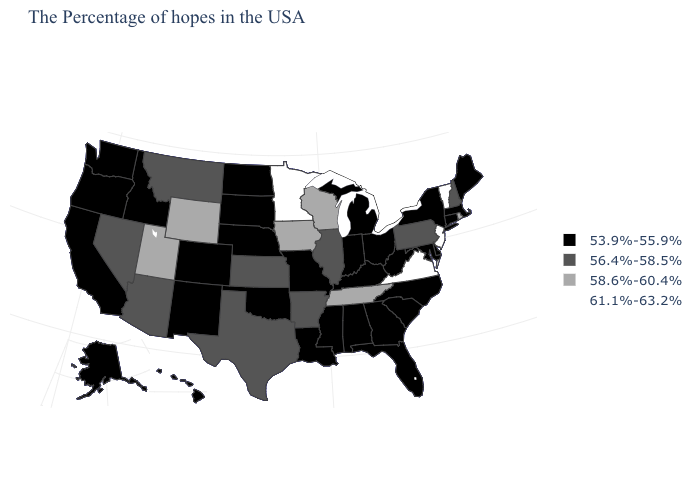Which states hav the highest value in the South?
Keep it brief. Virginia. What is the value of Arizona?
Give a very brief answer. 56.4%-58.5%. What is the highest value in the USA?
Keep it brief. 61.1%-63.2%. Which states have the lowest value in the USA?
Write a very short answer. Maine, Massachusetts, Connecticut, New York, Delaware, Maryland, North Carolina, South Carolina, West Virginia, Ohio, Florida, Georgia, Michigan, Kentucky, Indiana, Alabama, Mississippi, Louisiana, Missouri, Nebraska, Oklahoma, South Dakota, North Dakota, Colorado, New Mexico, Idaho, California, Washington, Oregon, Alaska, Hawaii. Name the states that have a value in the range 53.9%-55.9%?
Be succinct. Maine, Massachusetts, Connecticut, New York, Delaware, Maryland, North Carolina, South Carolina, West Virginia, Ohio, Florida, Georgia, Michigan, Kentucky, Indiana, Alabama, Mississippi, Louisiana, Missouri, Nebraska, Oklahoma, South Dakota, North Dakota, Colorado, New Mexico, Idaho, California, Washington, Oregon, Alaska, Hawaii. Which states have the lowest value in the USA?
Write a very short answer. Maine, Massachusetts, Connecticut, New York, Delaware, Maryland, North Carolina, South Carolina, West Virginia, Ohio, Florida, Georgia, Michigan, Kentucky, Indiana, Alabama, Mississippi, Louisiana, Missouri, Nebraska, Oklahoma, South Dakota, North Dakota, Colorado, New Mexico, Idaho, California, Washington, Oregon, Alaska, Hawaii. Does the first symbol in the legend represent the smallest category?
Answer briefly. Yes. Is the legend a continuous bar?
Quick response, please. No. Name the states that have a value in the range 58.6%-60.4%?
Answer briefly. Rhode Island, Tennessee, Wisconsin, Iowa, Wyoming, Utah. Does Rhode Island have the highest value in the USA?
Answer briefly. No. What is the value of Kentucky?
Answer briefly. 53.9%-55.9%. Does Indiana have a lower value than New York?
Keep it brief. No. Among the states that border Arkansas , does Tennessee have the highest value?
Quick response, please. Yes. What is the value of Tennessee?
Quick response, please. 58.6%-60.4%. Is the legend a continuous bar?
Be succinct. No. 